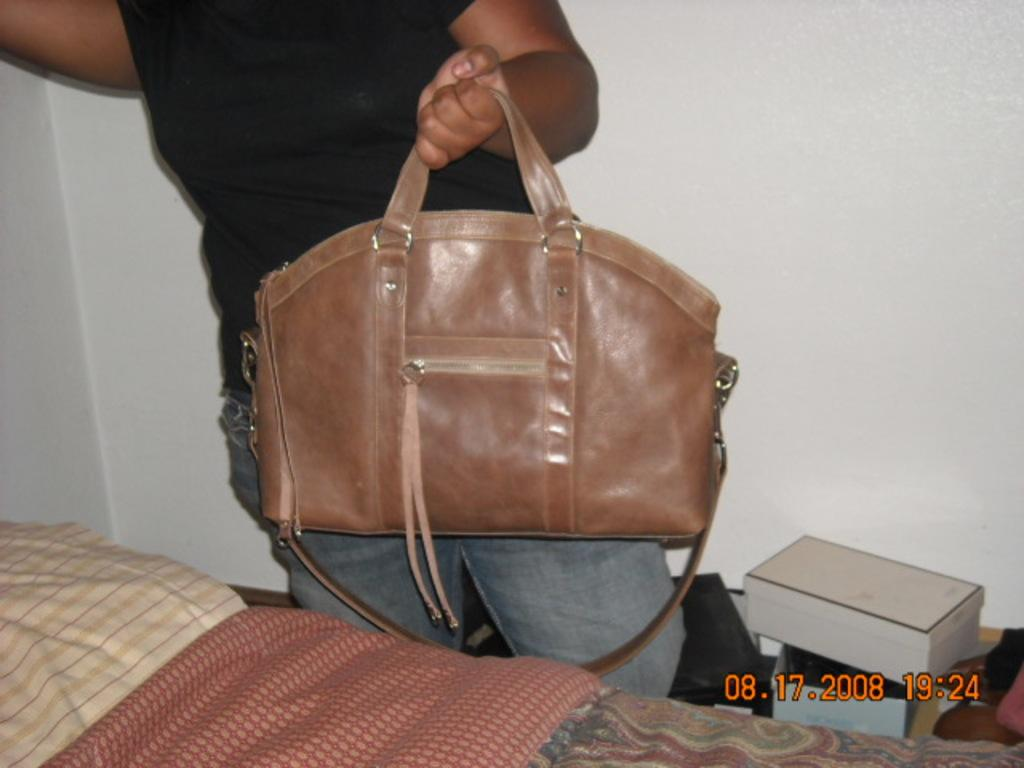Who or what is present in the image? There is a person in the image. What is the person holding? The person is holding a handbag. What type of furniture is visible in the image? There is a bed in the image. What type of ray can be seen flying in the image? There is no ray present in the image. 